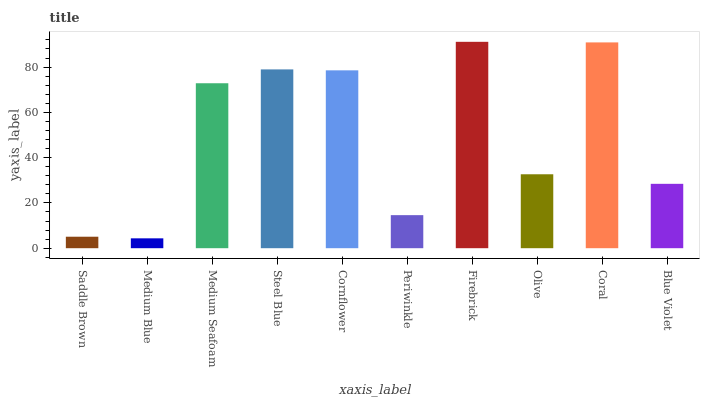Is Medium Blue the minimum?
Answer yes or no. Yes. Is Firebrick the maximum?
Answer yes or no. Yes. Is Medium Seafoam the minimum?
Answer yes or no. No. Is Medium Seafoam the maximum?
Answer yes or no. No. Is Medium Seafoam greater than Medium Blue?
Answer yes or no. Yes. Is Medium Blue less than Medium Seafoam?
Answer yes or no. Yes. Is Medium Blue greater than Medium Seafoam?
Answer yes or no. No. Is Medium Seafoam less than Medium Blue?
Answer yes or no. No. Is Medium Seafoam the high median?
Answer yes or no. Yes. Is Olive the low median?
Answer yes or no. Yes. Is Firebrick the high median?
Answer yes or no. No. Is Medium Blue the low median?
Answer yes or no. No. 